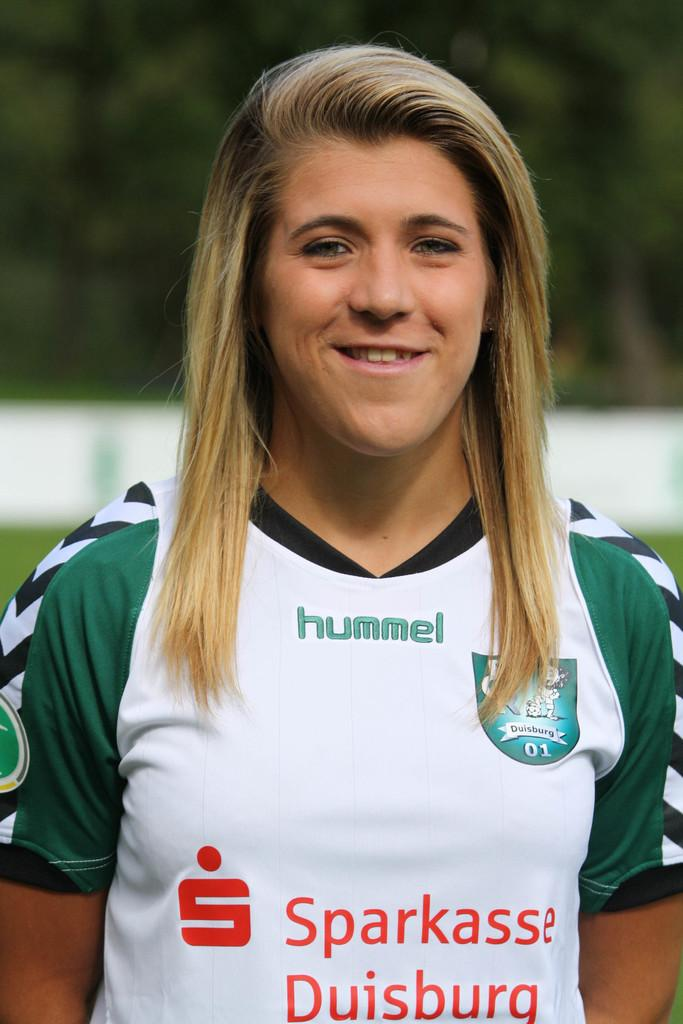Provide a one-sentence caption for the provided image. Young women in uniform, team jersey says hummel on the t-shirt. 